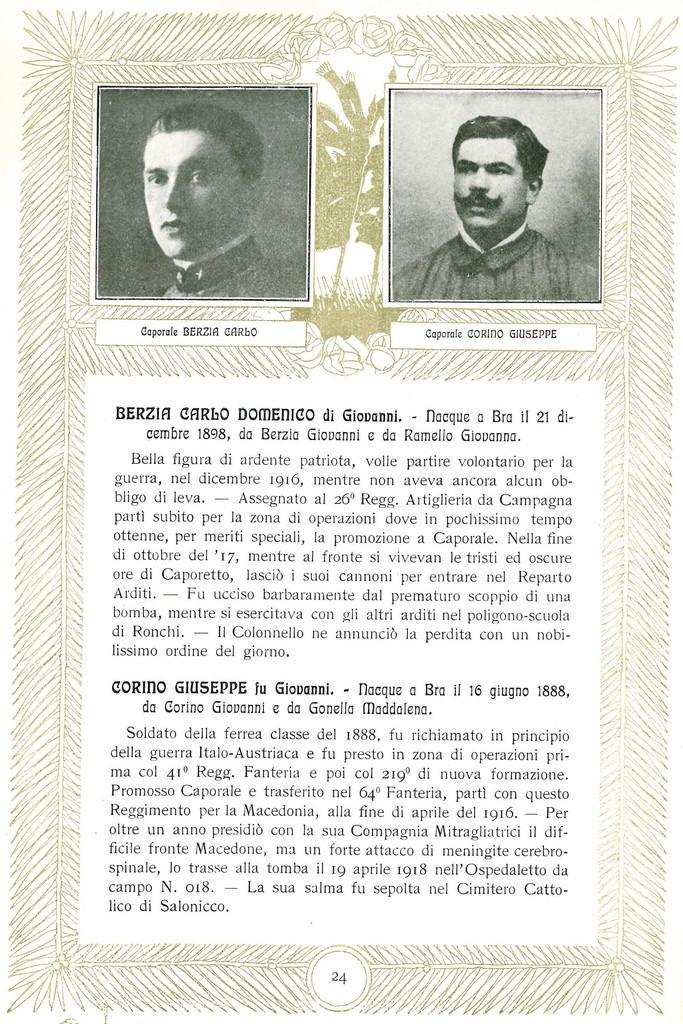How would you summarize this image in a sentence or two? In this image we can see a poster. In this image we can see pictures, text and some design. 